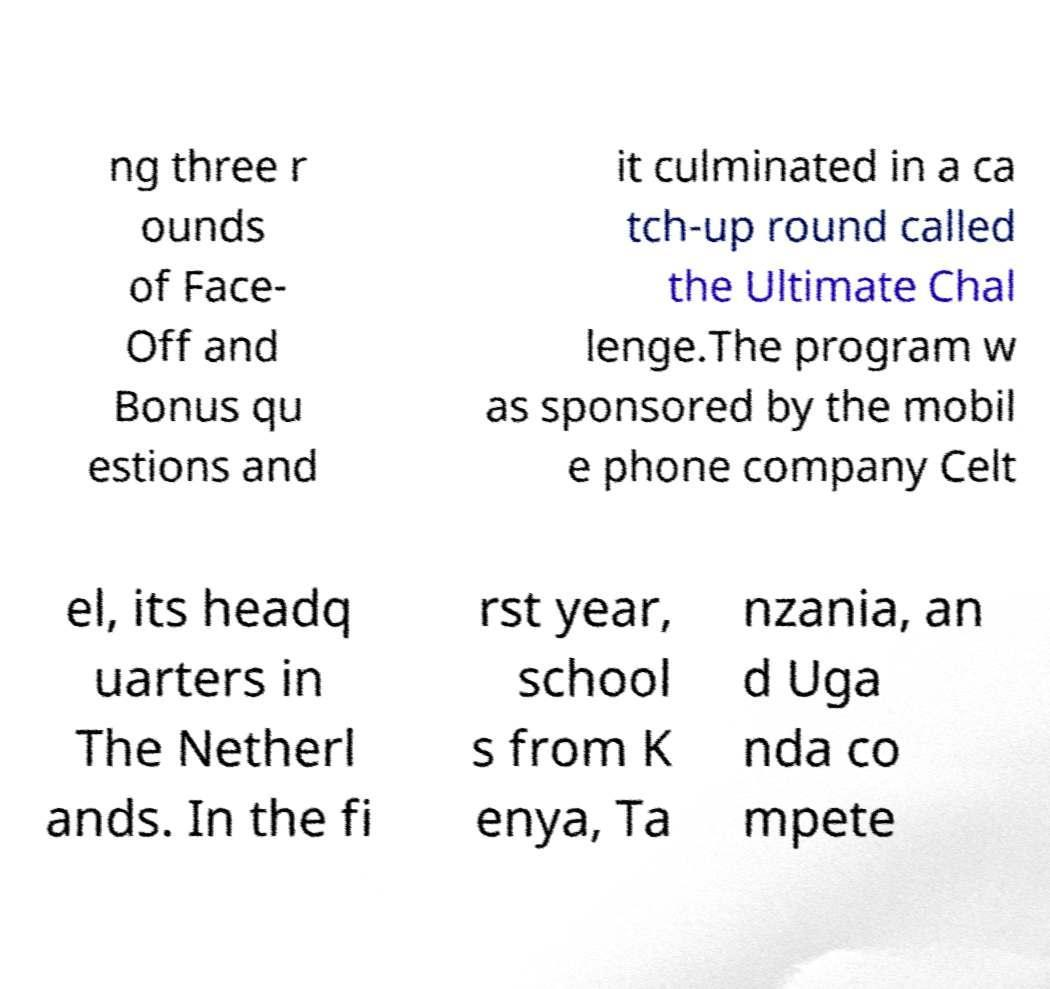Can you accurately transcribe the text from the provided image for me? ng three r ounds of Face- Off and Bonus qu estions and it culminated in a ca tch-up round called the Ultimate Chal lenge.The program w as sponsored by the mobil e phone company Celt el, its headq uarters in The Netherl ands. In the fi rst year, school s from K enya, Ta nzania, an d Uga nda co mpete 